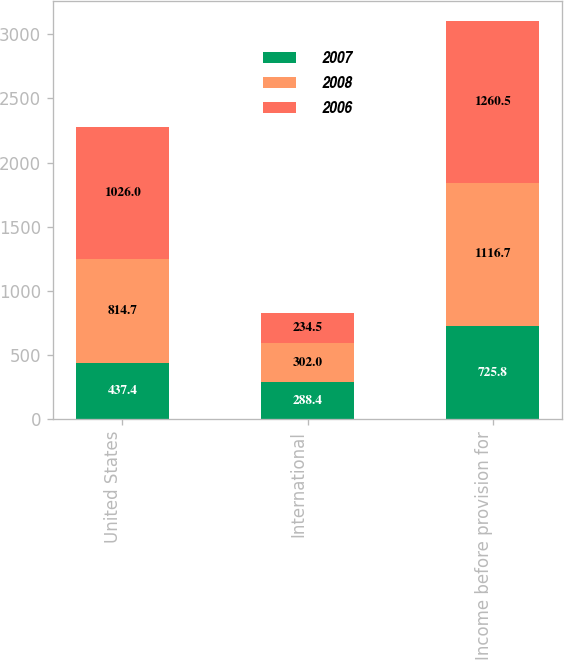<chart> <loc_0><loc_0><loc_500><loc_500><stacked_bar_chart><ecel><fcel>United States<fcel>International<fcel>Income before provision for<nl><fcel>2007<fcel>437.4<fcel>288.4<fcel>725.8<nl><fcel>2008<fcel>814.7<fcel>302<fcel>1116.7<nl><fcel>2006<fcel>1026<fcel>234.5<fcel>1260.5<nl></chart> 